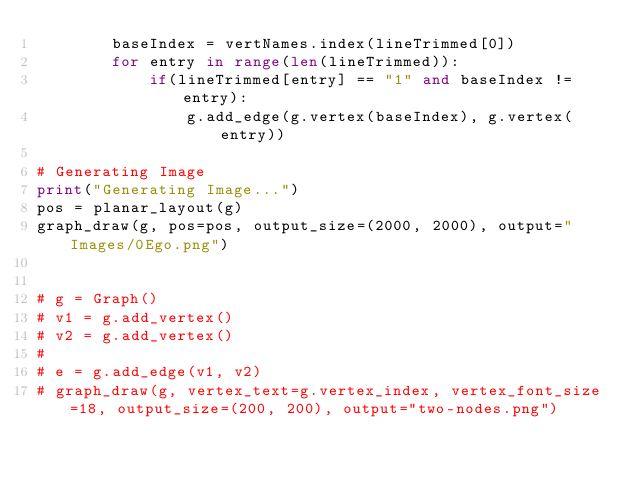<code> <loc_0><loc_0><loc_500><loc_500><_Python_>        baseIndex = vertNames.index(lineTrimmed[0])
        for entry in range(len(lineTrimmed)):
            if(lineTrimmed[entry] == "1" and baseIndex != entry):
                g.add_edge(g.vertex(baseIndex), g.vertex(entry))

# Generating Image
print("Generating Image...")
pos = planar_layout(g)
graph_draw(g, pos=pos, output_size=(2000, 2000), output="Images/0Ego.png")


# g = Graph()
# v1 = g.add_vertex()
# v2 = g.add_vertex()
#
# e = g.add_edge(v1, v2)
# graph_draw(g, vertex_text=g.vertex_index, vertex_font_size=18, output_size=(200, 200), output="two-nodes.png")
</code> 